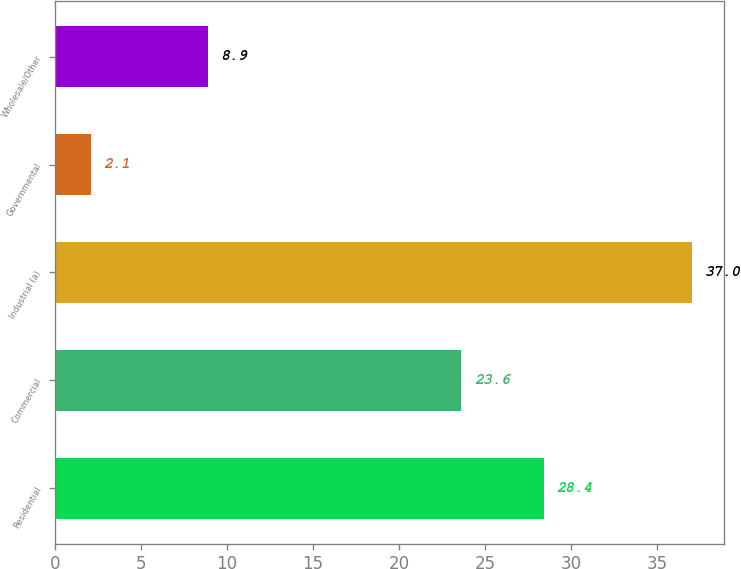Convert chart. <chart><loc_0><loc_0><loc_500><loc_500><bar_chart><fcel>Residential<fcel>Commercial<fcel>Industrial (a)<fcel>Governmental<fcel>Wholesale/Other<nl><fcel>28.4<fcel>23.6<fcel>37<fcel>2.1<fcel>8.9<nl></chart> 